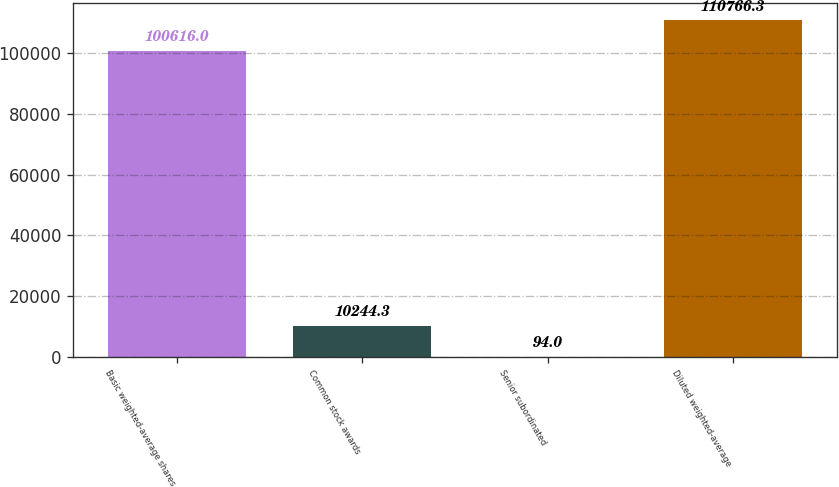Convert chart. <chart><loc_0><loc_0><loc_500><loc_500><bar_chart><fcel>Basic weighted-average shares<fcel>Common stock awards<fcel>Senior subordinated<fcel>Diluted weighted-average<nl><fcel>100616<fcel>10244.3<fcel>94<fcel>110766<nl></chart> 